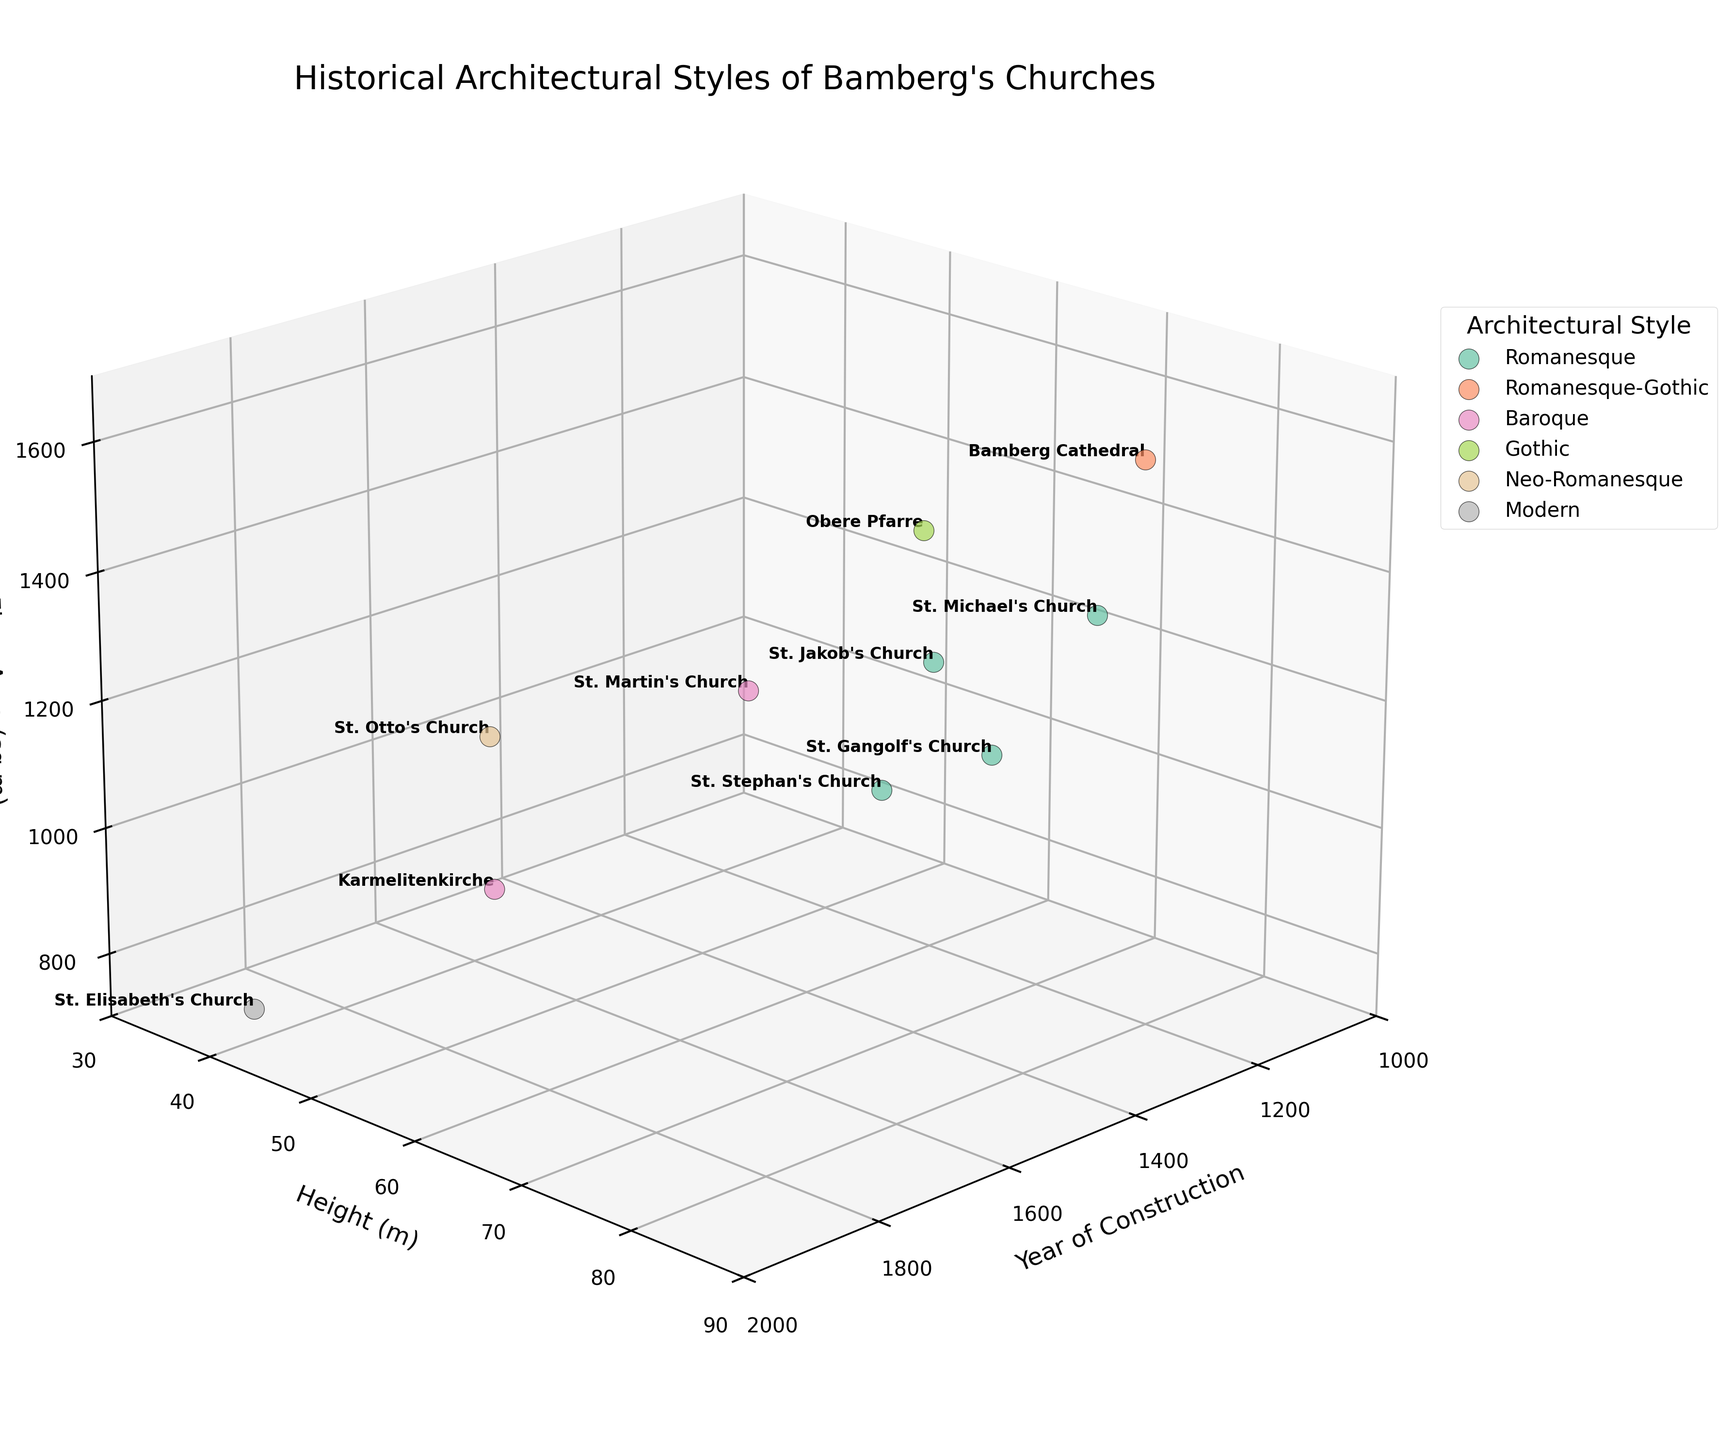What is the highest church in the figure? To determine the highest church, look at the y-axis which represents the height in meters. Identify the highest point on this axis and find the associated church name using the labels.
Answer: Bamberg Cathedral How many different architectural styles are represented in the plot? Observe the legend in the plot which indicates different architectural styles. Count the unique styles listed.
Answer: 5 Which church has the largest floor area? Look at the z-axis representing the floor area in square meters. Identify the maximum value on this axis and find the associated church name using the labels.
Answer: Bamberg Cathedral What is the time range of the construction years depicted in the plot? Examine the x-axis which represents the year of construction. Identify the earliest and the latest years marked by the data points.
Answer: 1015 to 1934 Which church has the smallest floor area and what is its architectural style? Look at the z-axis for the smallest floor area value. Find the corresponding church and identify its style by referring to the legend.
Answer: St. Elisabeth's Church, Modern How many churches were built before the year 1500? Check the x-axis and count the data points that are before the year 1500.
Answer: 6 Compare the heights of St. Michael's Church and Obere Pfarre. Which one is taller and by how much? Locate St. Michael's Church and Obere Pfarre on the plot, check their y-axis values (heights), and calculate the difference.
Answer: Obere Pfarre by 2 meters What is the average floor area of the Romanesque churches? Identify all Romanesque churches from the legend, sum their floor areas (on the z-axis), and divide by the number of these churches.
Answer: 1020 square meters Which church built in the modern era has the smallest height? Identify the modern architectural style in the legend and check the y-axis (height) values for these churches. Find the smallest value and the associated church name.
Answer: St. Elisabeth's Church 